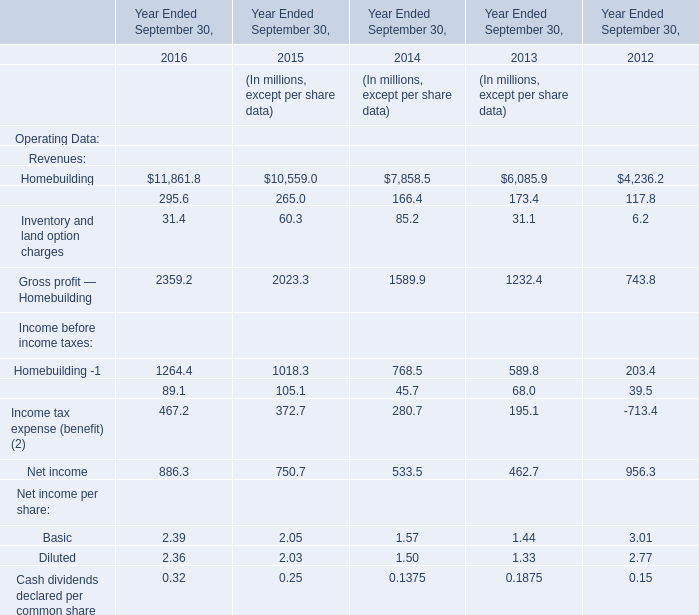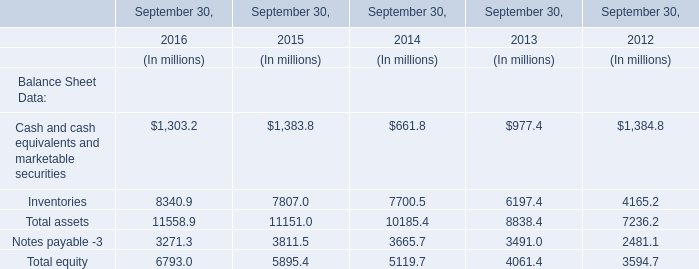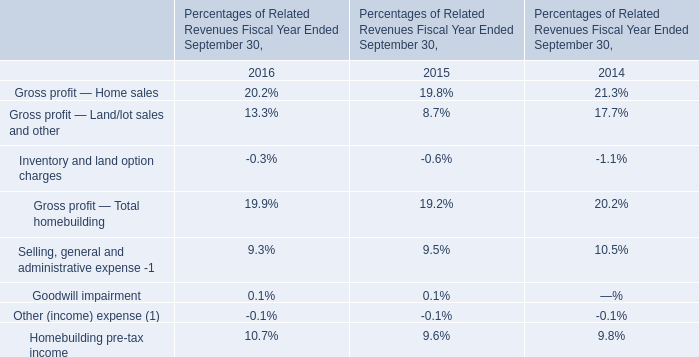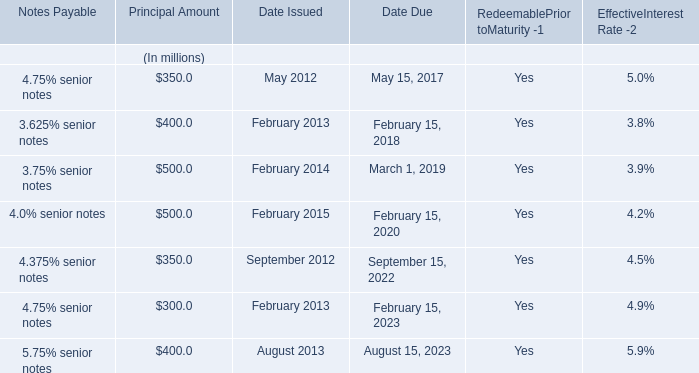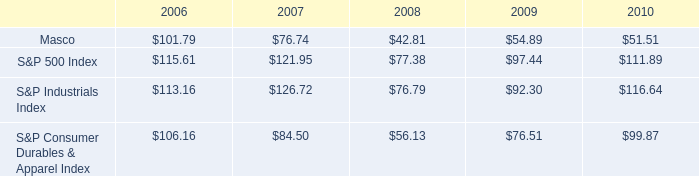What is the growing rate of Home building in the years with the least Inventory and land option charges? 
Computations: ((6085.9 - 4236.2) / 4236.2)
Answer: 0.43664. 